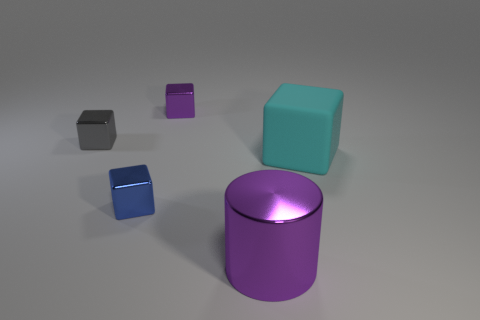What number of blue things are the same size as the purple metal block?
Your answer should be very brief. 1. What is the shape of the tiny metal object that is the same color as the metallic cylinder?
Make the answer very short. Cube. How many objects are small shiny things that are behind the blue thing or cyan cubes?
Ensure brevity in your answer.  3. Is the number of big purple cylinders less than the number of objects?
Provide a succinct answer. Yes. There is a blue thing that is made of the same material as the tiny gray block; what is its shape?
Provide a short and direct response. Cube. There is a cyan block; are there any metallic cubes in front of it?
Keep it short and to the point. Yes. Is the number of small purple metal things on the right side of the big cyan block less than the number of blue shiny balls?
Your answer should be very brief. No. What is the material of the purple cylinder?
Your answer should be very brief. Metal. What is the color of the big rubber block?
Make the answer very short. Cyan. There is a shiny thing that is both in front of the small gray shiny thing and behind the purple cylinder; what is its color?
Your answer should be compact. Blue. 